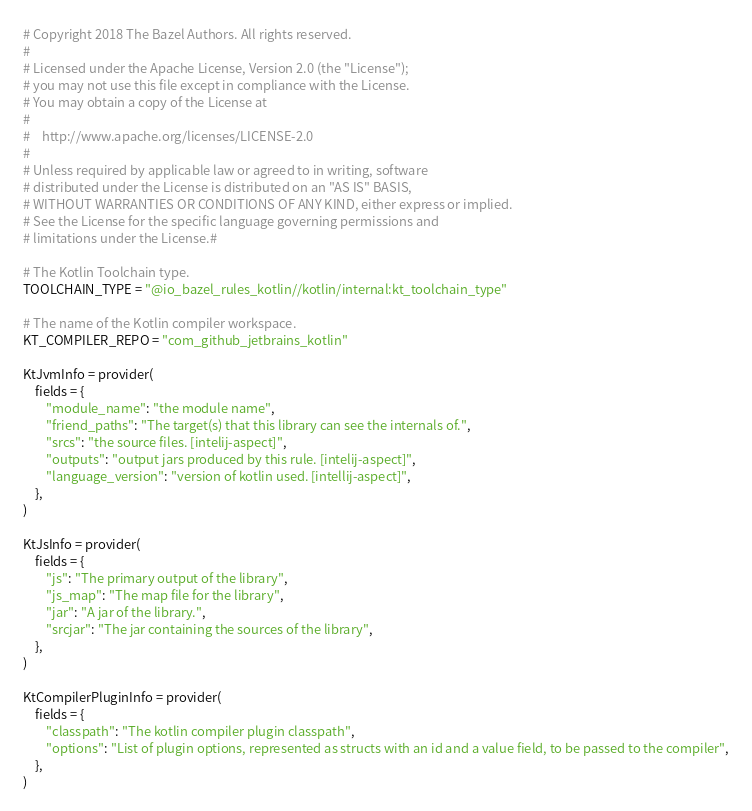Convert code to text. <code><loc_0><loc_0><loc_500><loc_500><_Python_># Copyright 2018 The Bazel Authors. All rights reserved.
#
# Licensed under the Apache License, Version 2.0 (the "License");
# you may not use this file except in compliance with the License.
# You may obtain a copy of the License at
#
#    http://www.apache.org/licenses/LICENSE-2.0
#
# Unless required by applicable law or agreed to in writing, software
# distributed under the License is distributed on an "AS IS" BASIS,
# WITHOUT WARRANTIES OR CONDITIONS OF ANY KIND, either express or implied.
# See the License for the specific language governing permissions and
# limitations under the License.#

# The Kotlin Toolchain type.
TOOLCHAIN_TYPE = "@io_bazel_rules_kotlin//kotlin/internal:kt_toolchain_type"

# The name of the Kotlin compiler workspace.
KT_COMPILER_REPO = "com_github_jetbrains_kotlin"

KtJvmInfo = provider(
    fields = {
        "module_name": "the module name",
        "friend_paths": "The target(s) that this library can see the internals of.",
        "srcs": "the source files. [intelij-aspect]",
        "outputs": "output jars produced by this rule. [intelij-aspect]",
        "language_version": "version of kotlin used. [intellij-aspect]",
    },
)

KtJsInfo = provider(
    fields = {
        "js": "The primary output of the library",
        "js_map": "The map file for the library",
        "jar": "A jar of the library.",
        "srcjar": "The jar containing the sources of the library",
    },
)

KtCompilerPluginInfo = provider(
    fields = {
        "classpath": "The kotlin compiler plugin classpath",
        "options": "List of plugin options, represented as structs with an id and a value field, to be passed to the compiler",
    },
)
</code> 